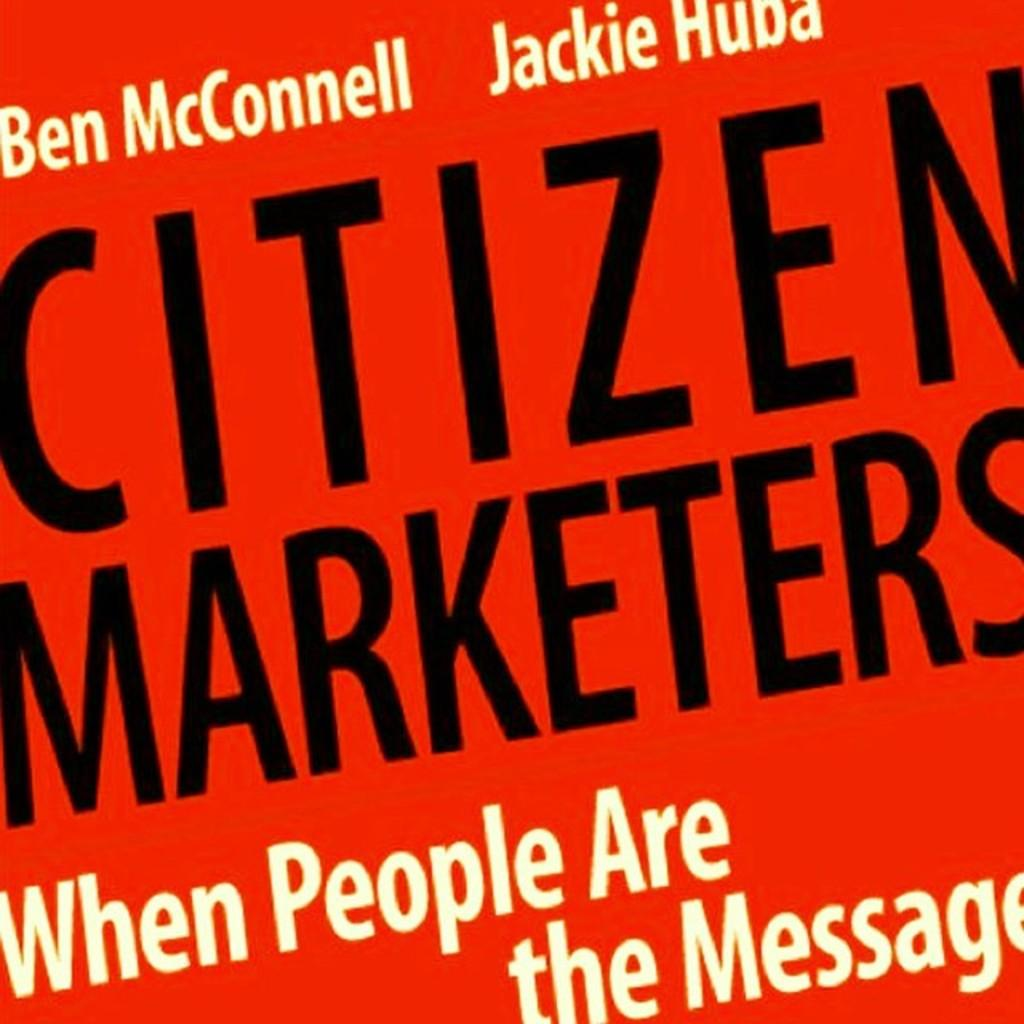Provide a one-sentence caption for the provided image. A red sign titled Citizens Marketers, when people are the message. 